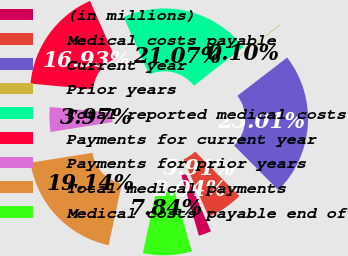Convert chart to OTSL. <chart><loc_0><loc_0><loc_500><loc_500><pie_chart><fcel>(in millions)<fcel>Medical costs payable<fcel>Current year<fcel>Prior years<fcel>Total reported medical costs<fcel>Payments for current year<fcel>Payments for prior years<fcel>Total medical payments<fcel>Medical costs payable end of<nl><fcel>2.04%<fcel>5.91%<fcel>23.01%<fcel>0.1%<fcel>21.07%<fcel>16.93%<fcel>3.97%<fcel>19.14%<fcel>7.84%<nl></chart> 